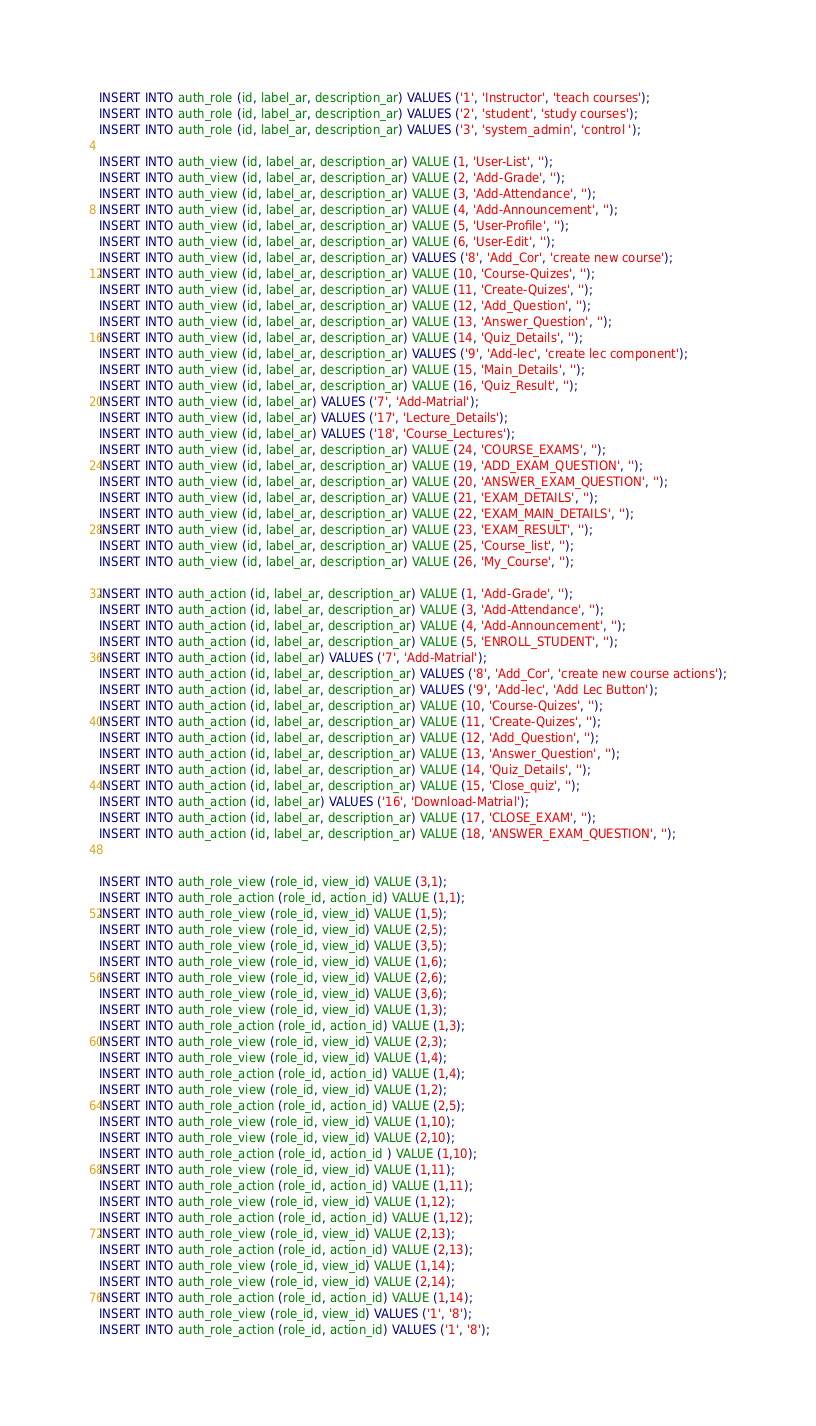Convert code to text. <code><loc_0><loc_0><loc_500><loc_500><_SQL_>INSERT INTO auth_role (id, label_ar, description_ar) VALUES ('1', 'Instructor', 'teach courses');
INSERT INTO auth_role (id, label_ar, description_ar) VALUES ('2', 'student', 'study courses');
INSERT INTO auth_role (id, label_ar, description_ar) VALUES ('3', 'system_admin', 'control ');

INSERT INTO auth_view (id, label_ar, description_ar) VALUE (1, 'User-List', '');
INSERT INTO auth_view (id, label_ar, description_ar) VALUE (2, 'Add-Grade', '');
INSERT INTO auth_view (id, label_ar, description_ar) VALUE (3, 'Add-Attendance', '');
INSERT INTO auth_view (id, label_ar, description_ar) VALUE (4, 'Add-Announcement', '');
INSERT INTO auth_view (id, label_ar, description_ar) VALUE (5, 'User-Profile', '');
INSERT INTO auth_view (id, label_ar, description_ar) VALUE (6, 'User-Edit', '');
INSERT INTO auth_view (id, label_ar, description_ar) VALUES ('8', 'Add_Cor', 'create new course');
INSERT INTO auth_view (id, label_ar, description_ar) VALUE (10, 'Course-Quizes', '');
INSERT INTO auth_view (id, label_ar, description_ar) VALUE (11, 'Create-Quizes', '');
INSERT INTO auth_view (id, label_ar, description_ar) VALUE (12, 'Add_Question', '');
INSERT INTO auth_view (id, label_ar, description_ar) VALUE (13, 'Answer_Question', '');
INSERT INTO auth_view (id, label_ar, description_ar) VALUE (14, 'Quiz_Details', '');
INSERT INTO auth_view (id, label_ar, description_ar) VALUES ('9', 'Add-lec', 'create lec component');
INSERT INTO auth_view (id, label_ar, description_ar) VALUE (15, 'Main_Details', '');
INSERT INTO auth_view (id, label_ar, description_ar) VALUE (16, 'Quiz_Result', '');
INSERT INTO auth_view (id, label_ar) VALUES ('7', 'Add-Matrial');
INSERT INTO auth_view (id, label_ar) VALUES ('17', 'Lecture_Details');
INSERT INTO auth_view (id, label_ar) VALUES ('18', 'Course_Lectures');
INSERT INTO auth_view (id, label_ar, description_ar) VALUE (24, 'COURSE_EXAMS', '');
INSERT INTO auth_view (id, label_ar, description_ar) VALUE (19, 'ADD_EXAM_QUESTION', '');
INSERT INTO auth_view (id, label_ar, description_ar) VALUE (20, 'ANSWER_EXAM_QUESTION', '');
INSERT INTO auth_view (id, label_ar, description_ar) VALUE (21, 'EXAM_DETAILS', '');
INSERT INTO auth_view (id, label_ar, description_ar) VALUE (22, 'EXAM_MAIN_DETAILS', '');
INSERT INTO auth_view (id, label_ar, description_ar) VALUE (23, 'EXAM_RESULT', '');
INSERT INTO auth_view (id, label_ar, description_ar) VALUE (25, 'Course_list', '');
INSERT INTO auth_view (id, label_ar, description_ar) VALUE (26, 'My_Course', '');

INSERT INTO auth_action (id, label_ar, description_ar) VALUE (1, 'Add-Grade', '');
INSERT INTO auth_action (id, label_ar, description_ar) VALUE (3, 'Add-Attendance', '');
INSERT INTO auth_action (id, label_ar, description_ar) VALUE (4, 'Add-Announcement', '');
INSERT INTO auth_action (id, label_ar, description_ar) VALUE (5, 'ENROLL_STUDENT', '');
INSERT INTO auth_action (id, label_ar) VALUES ('7', 'Add-Matrial');
INSERT INTO auth_action (id, label_ar, description_ar) VALUES ('8', 'Add_Cor', 'create new course actions');
INSERT INTO auth_action (id, label_ar, description_ar) VALUES ('9', 'Add-lec', 'Add Lec Button');
INSERT INTO auth_action (id, label_ar, description_ar) VALUE (10, 'Course-Quizes', '');
INSERT INTO auth_action (id, label_ar, description_ar) VALUE (11, 'Create-Quizes', '');
INSERT INTO auth_action (id, label_ar, description_ar) VALUE (12, 'Add_Question', '');
INSERT INTO auth_action (id, label_ar, description_ar) VALUE (13, 'Answer_Question', '');
INSERT INTO auth_action (id, label_ar, description_ar) VALUE (14, 'Quiz_Details', '');
INSERT INTO auth_action (id, label_ar, description_ar) VALUE (15, 'Close_quiz', '');
INSERT INTO auth_action (id, label_ar) VALUES ('16', 'Download-Matrial');
INSERT INTO auth_action (id, label_ar, description_ar) VALUE (17, 'CLOSE_EXAM', '');
INSERT INTO auth_action (id, label_ar, description_ar) VALUE (18, 'ANSWER_EXAM_QUESTION', '');


INSERT INTO auth_role_view (role_id, view_id) VALUE (3,1);
INSERT INTO auth_role_action (role_id, action_id) VALUE (1,1);
INSERT INTO auth_role_view (role_id, view_id) VALUE (1,5);
INSERT INTO auth_role_view (role_id, view_id) VALUE (2,5);
INSERT INTO auth_role_view (role_id, view_id) VALUE (3,5);
INSERT INTO auth_role_view (role_id, view_id) VALUE (1,6);
INSERT INTO auth_role_view (role_id, view_id) VALUE (2,6);
INSERT INTO auth_role_view (role_id, view_id) VALUE (3,6);
INSERT INTO auth_role_view (role_id, view_id) VALUE (1,3);
INSERT INTO auth_role_action (role_id, action_id) VALUE (1,3);
INSERT INTO auth_role_view (role_id, view_id) VALUE (2,3);
INSERT INTO auth_role_view (role_id, view_id) VALUE (1,4);
INSERT INTO auth_role_action (role_id, action_id) VALUE (1,4);
INSERT INTO auth_role_view (role_id, view_id) VALUE (1,2);
INSERT INTO auth_role_action (role_id, action_id) VALUE (2,5);
INSERT INTO auth_role_view (role_id, view_id) VALUE (1,10);
INSERT INTO auth_role_view (role_id, view_id) VALUE (2,10);
INSERT INTO auth_role_action (role_id, action_id ) VALUE (1,10);
INSERT INTO auth_role_view (role_id, view_id) VALUE (1,11);
INSERT INTO auth_role_action (role_id, action_id) VALUE (1,11);
INSERT INTO auth_role_view (role_id, view_id) VALUE (1,12);
INSERT INTO auth_role_action (role_id, action_id) VALUE (1,12);
INSERT INTO auth_role_view (role_id, view_id) VALUE (2,13);
INSERT INTO auth_role_action (role_id, action_id) VALUE (2,13);
INSERT INTO auth_role_view (role_id, view_id) VALUE (1,14);
INSERT INTO auth_role_view (role_id, view_id) VALUE (2,14);
INSERT INTO auth_role_action (role_id, action_id) VALUE (1,14);
INSERT INTO auth_role_view (role_id, view_id) VALUES ('1', '8');
INSERT INTO auth_role_action (role_id, action_id) VALUES ('1', '8');</code> 